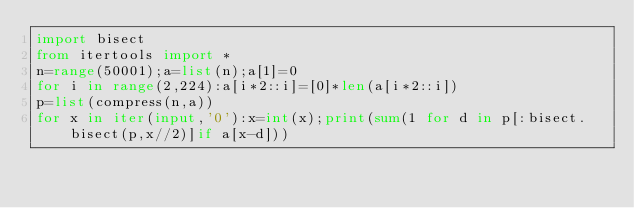<code> <loc_0><loc_0><loc_500><loc_500><_Python_>import bisect
from itertools import *
n=range(50001);a=list(n);a[1]=0
for i in range(2,224):a[i*2::i]=[0]*len(a[i*2::i])
p=list(compress(n,a))
for x in iter(input,'0'):x=int(x);print(sum(1 for d in p[:bisect.bisect(p,x//2)]if a[x-d]))
</code> 